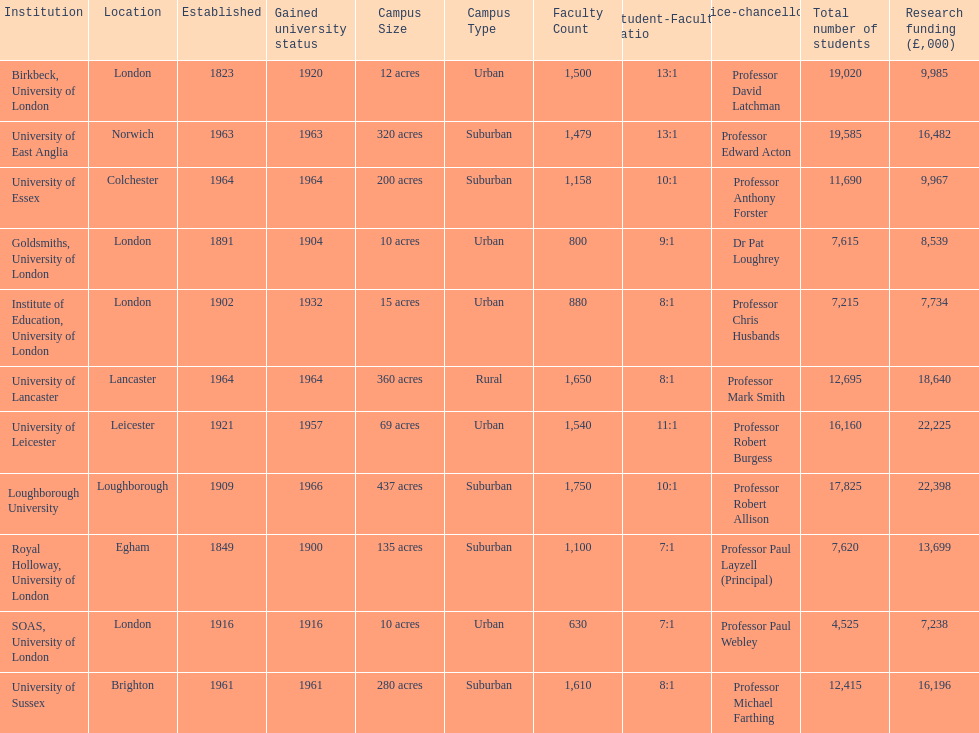Which institution has the most research funding? Loughborough University. 